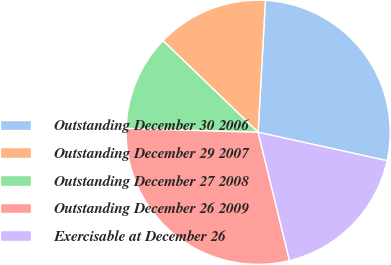Convert chart to OTSL. <chart><loc_0><loc_0><loc_500><loc_500><pie_chart><fcel>Outstanding December 30 2006<fcel>Outstanding December 29 2007<fcel>Outstanding December 27 2008<fcel>Outstanding December 26 2009<fcel>Exercisable at December 26<nl><fcel>27.57%<fcel>13.68%<fcel>11.74%<fcel>29.28%<fcel>17.73%<nl></chart> 